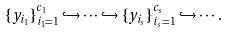Convert formula to latex. <formula><loc_0><loc_0><loc_500><loc_500>\{ y _ { i _ { 1 } } \} _ { i _ { 1 } = 1 } ^ { c _ { 1 } } \hookrightarrow \cdots \hookrightarrow \{ y _ { i _ { s } } \} _ { i _ { s } = 1 } ^ { c _ { s } } \hookrightarrow \cdots .</formula> 